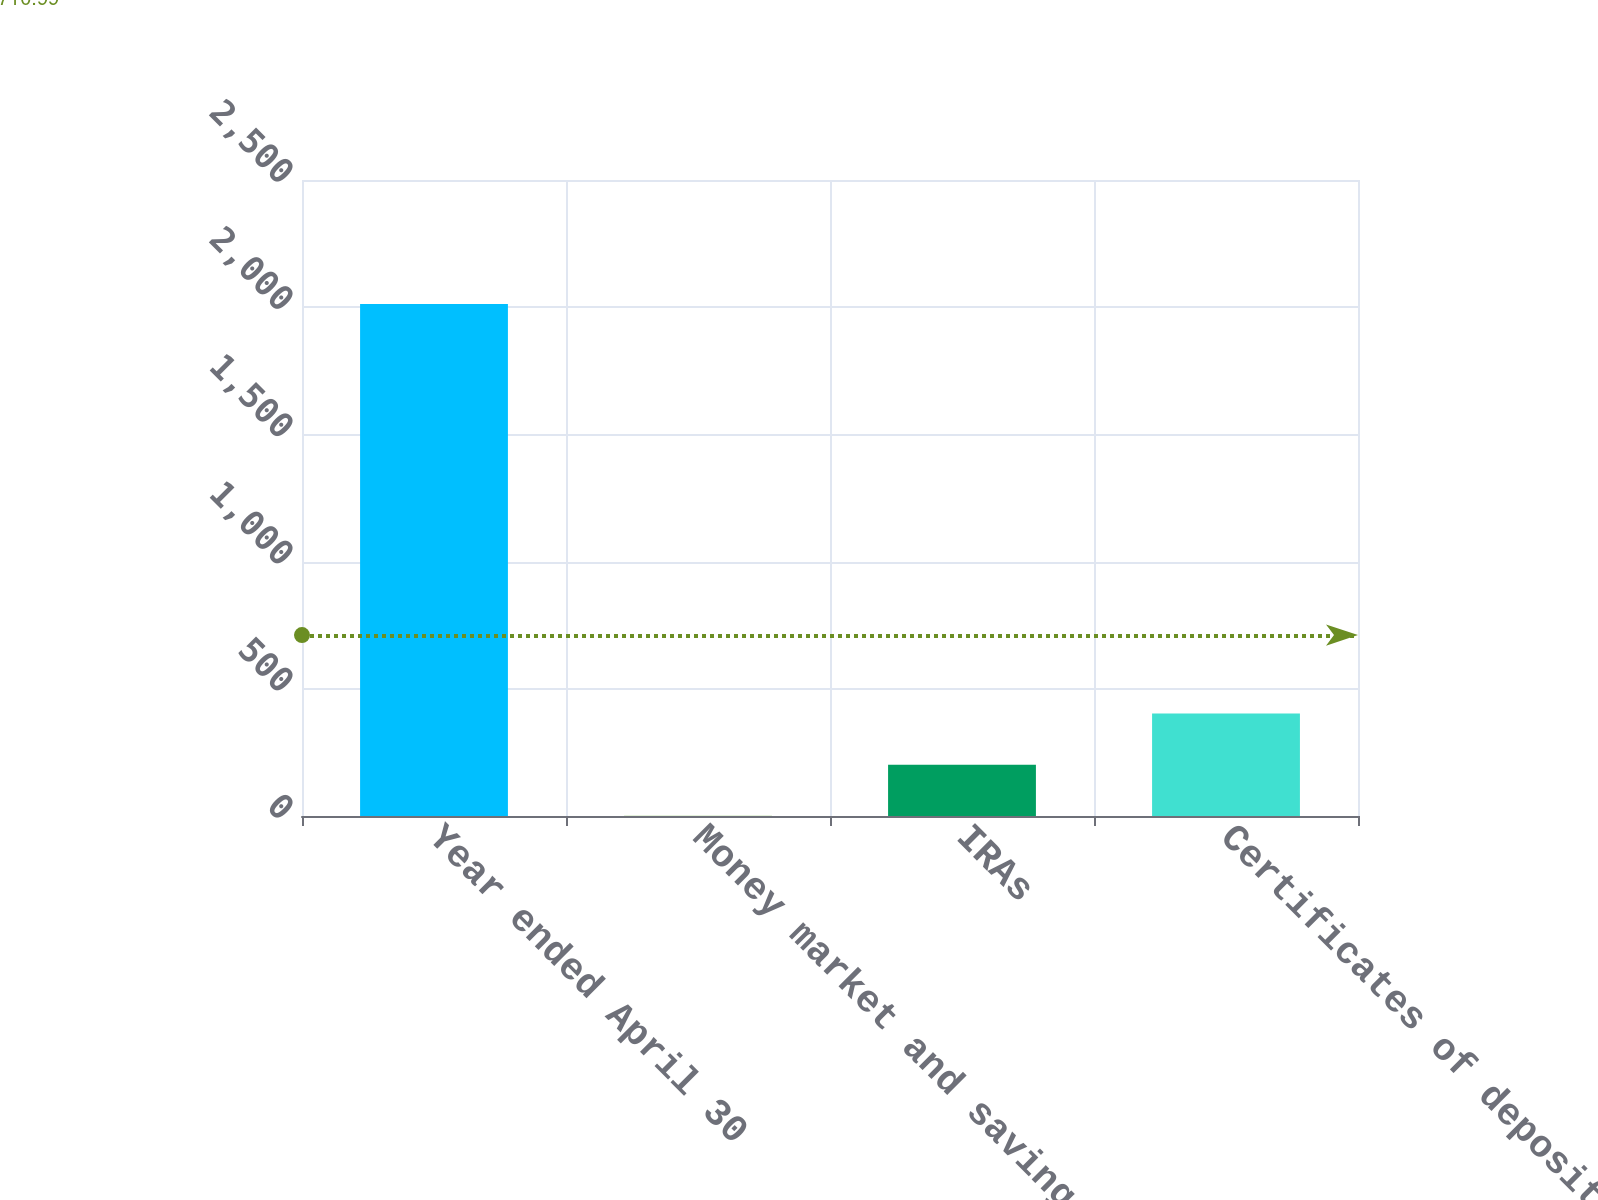<chart> <loc_0><loc_0><loc_500><loc_500><bar_chart><fcel>Year ended April 30<fcel>Money market and savings<fcel>IRAs<fcel>Certificates of deposit<nl><fcel>2013<fcel>0.59<fcel>201.83<fcel>403.07<nl></chart> 